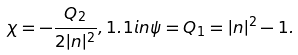Convert formula to latex. <formula><loc_0><loc_0><loc_500><loc_500>\chi = - \frac { Q _ { 2 } } { 2 | n | ^ { 2 } } , 1 . 1 i n \psi = Q _ { 1 } = | n | ^ { 2 } - 1 .</formula> 